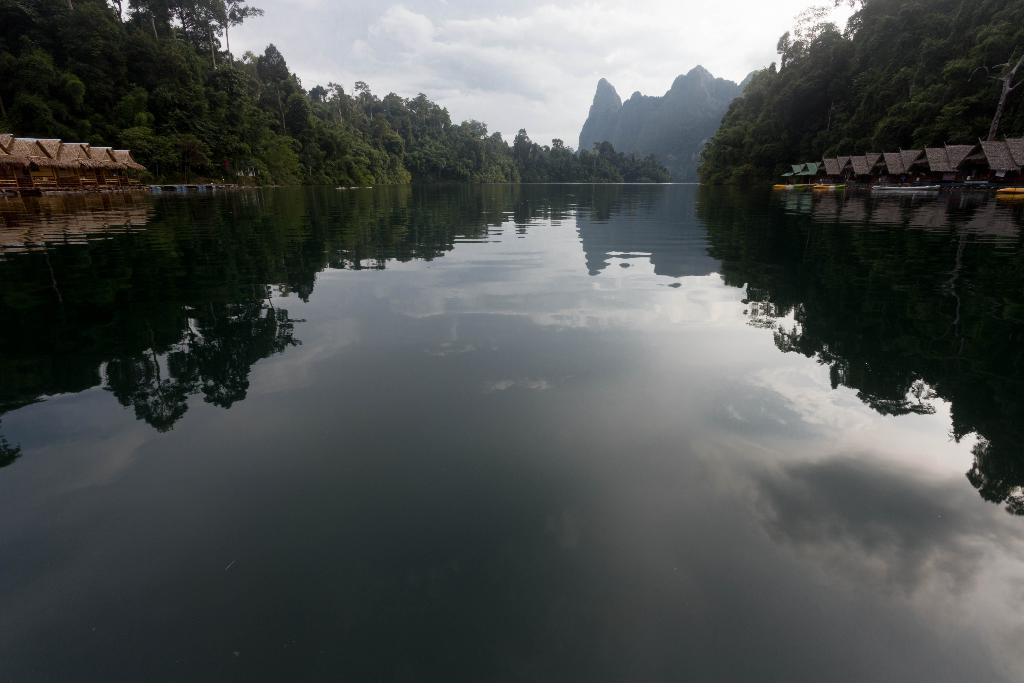What is the primary element visible in the image? There is water in the image. Where are the houses located in the image? There are houses on both the left and right sides of the image. What type of vegetation can be seen in the image? There are trees in the image. What is visible in the background of the image? There is a hill and the sky visible in the background of the image. What type of sink can be seen in the image? There is no sink present in the image. How many bushes are visible in the image? There is no mention of bushes in the provided facts, so we cannot determine their presence or quantity in the image. 